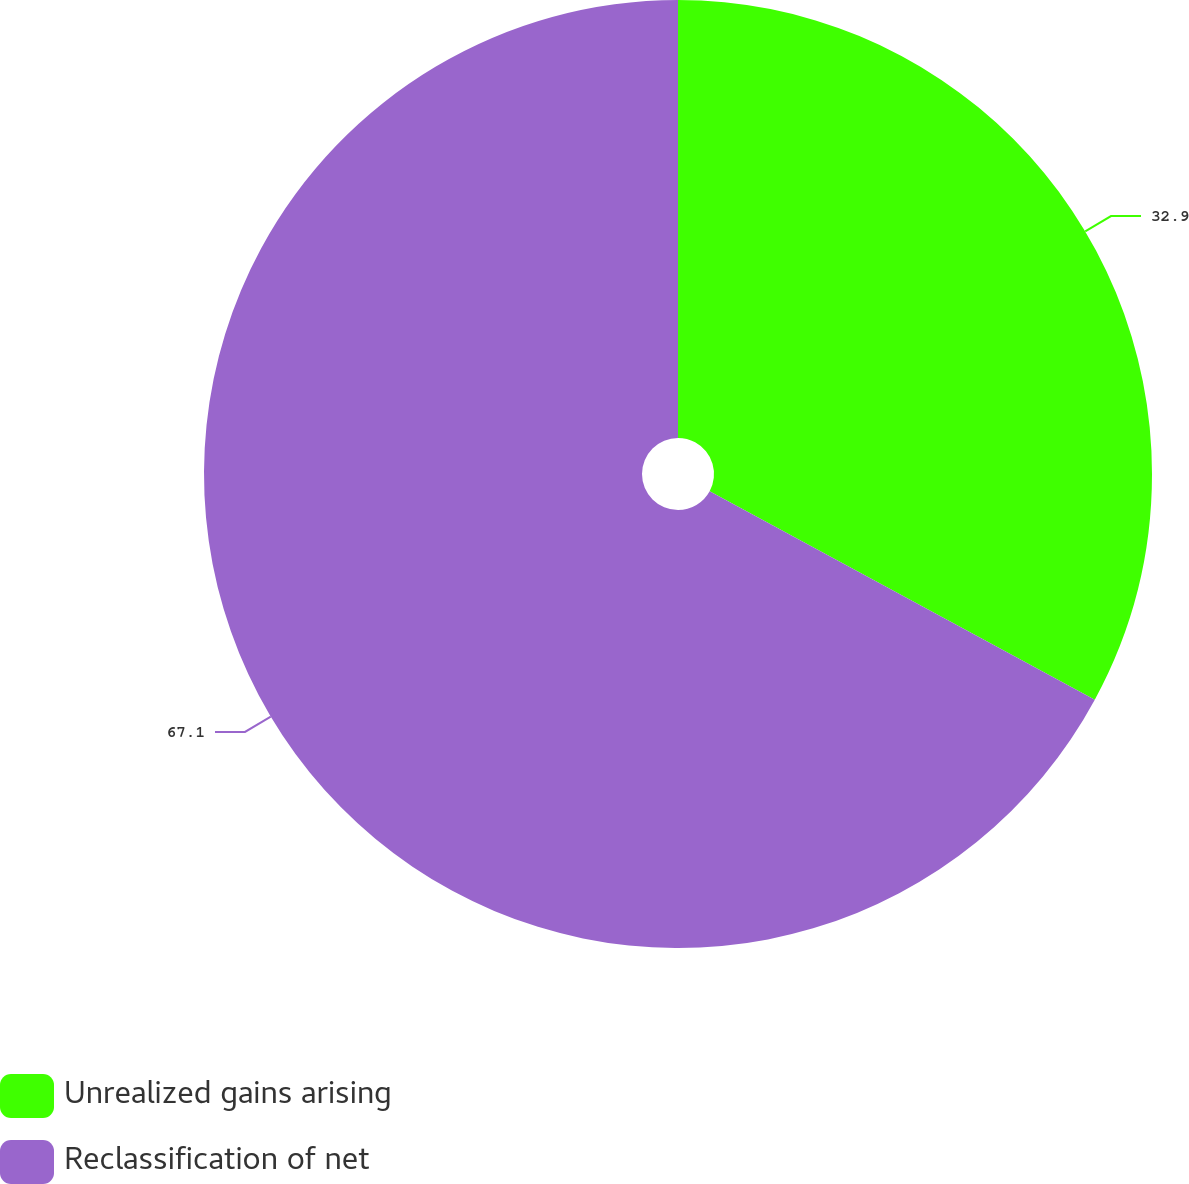<chart> <loc_0><loc_0><loc_500><loc_500><pie_chart><fcel>Unrealized gains arising<fcel>Reclassification of net<nl><fcel>32.9%<fcel>67.1%<nl></chart> 